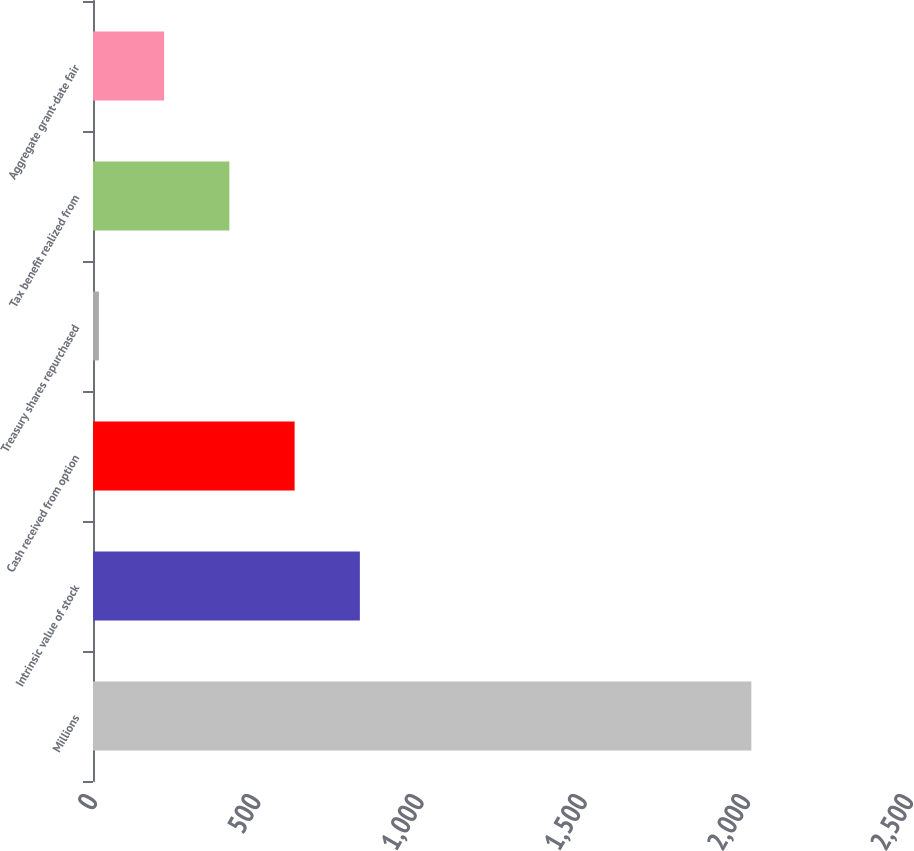Convert chart. <chart><loc_0><loc_0><loc_500><loc_500><bar_chart><fcel>Millions<fcel>Intrinsic value of stock<fcel>Cash received from option<fcel>Treasury shares repurchased<fcel>Tax benefit realized from<fcel>Aggregate grant-date fair<nl><fcel>2017<fcel>817.6<fcel>617.7<fcel>18<fcel>417.8<fcel>217.9<nl></chart> 